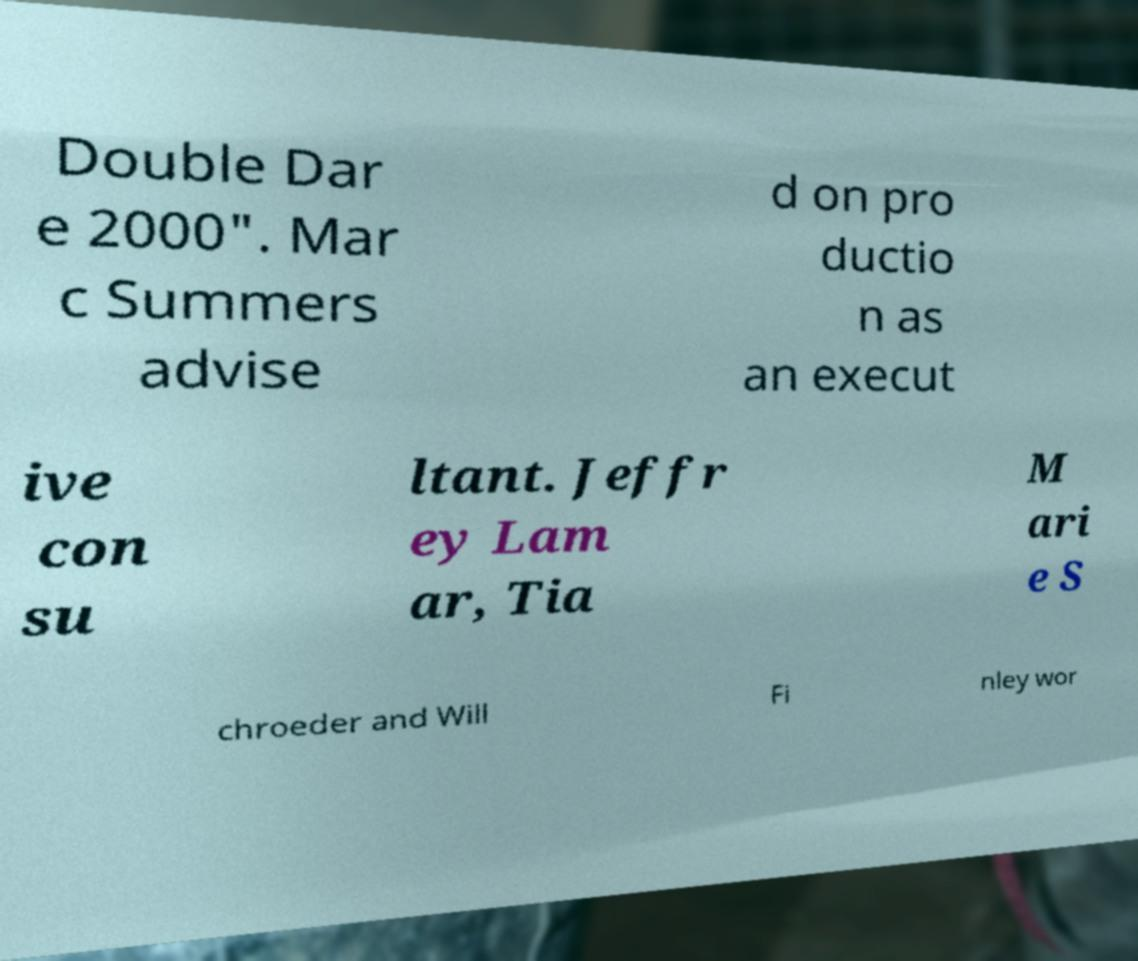There's text embedded in this image that I need extracted. Can you transcribe it verbatim? Double Dar e 2000". Mar c Summers advise d on pro ductio n as an execut ive con su ltant. Jeffr ey Lam ar, Tia M ari e S chroeder and Will Fi nley wor 